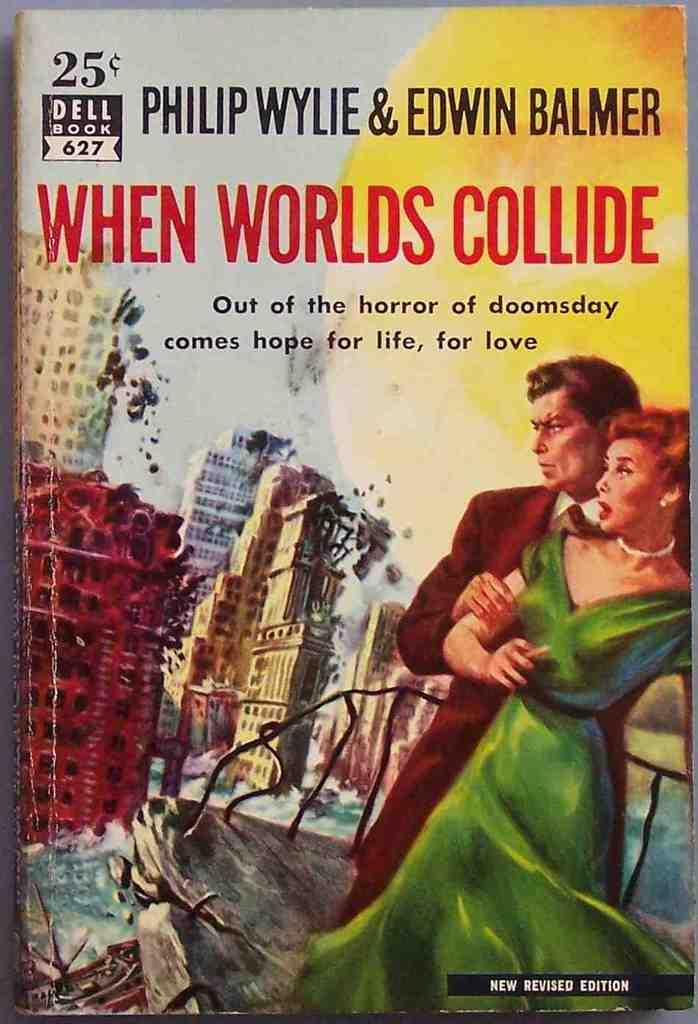<image>
Summarize the visual content of the image. A cover for a book titled "When Worlds Collide". 